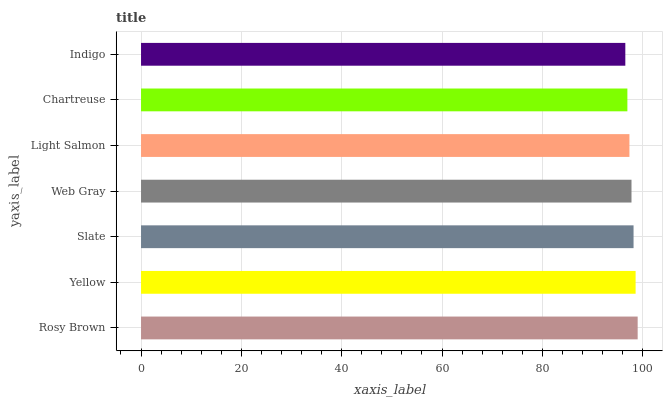Is Indigo the minimum?
Answer yes or no. Yes. Is Rosy Brown the maximum?
Answer yes or no. Yes. Is Yellow the minimum?
Answer yes or no. No. Is Yellow the maximum?
Answer yes or no. No. Is Rosy Brown greater than Yellow?
Answer yes or no. Yes. Is Yellow less than Rosy Brown?
Answer yes or no. Yes. Is Yellow greater than Rosy Brown?
Answer yes or no. No. Is Rosy Brown less than Yellow?
Answer yes or no. No. Is Web Gray the high median?
Answer yes or no. Yes. Is Web Gray the low median?
Answer yes or no. Yes. Is Light Salmon the high median?
Answer yes or no. No. Is Yellow the low median?
Answer yes or no. No. 